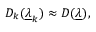<formula> <loc_0><loc_0><loc_500><loc_500>D _ { k } ( \underline { \lambda } _ { k } ) \approx D ( \underline { \lambda } ) ,</formula> 